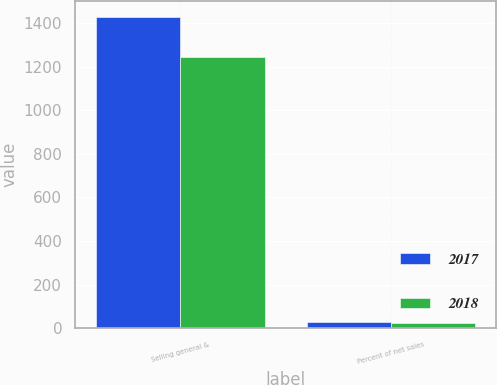Convert chart to OTSL. <chart><loc_0><loc_0><loc_500><loc_500><stacked_bar_chart><ecel><fcel>Selling general &<fcel>Percent of net sales<nl><fcel>2017<fcel>1429.5<fcel>26.4<nl><fcel>2018<fcel>1244.8<fcel>25.8<nl></chart> 